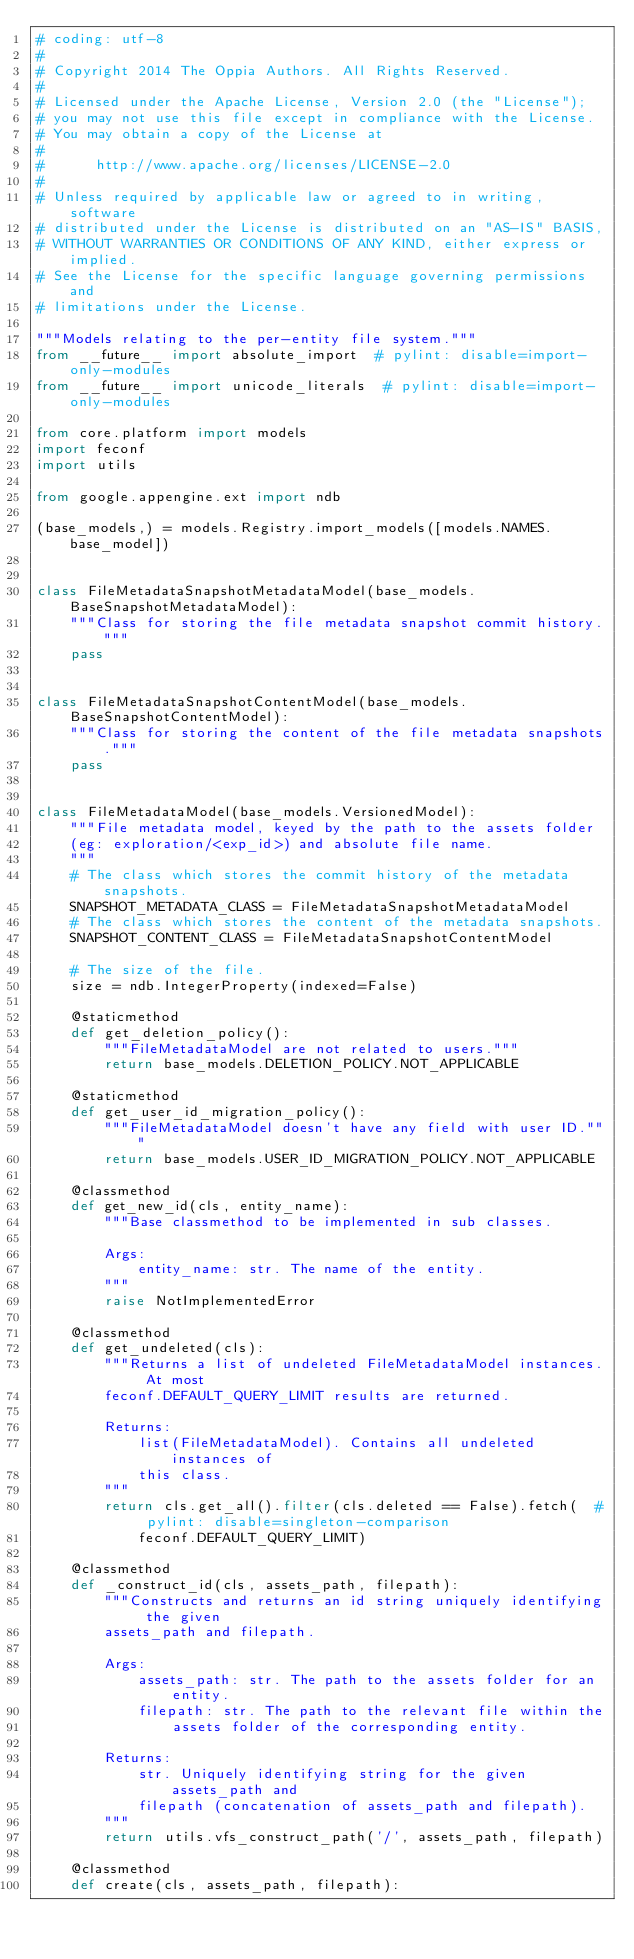Convert code to text. <code><loc_0><loc_0><loc_500><loc_500><_Python_># coding: utf-8
#
# Copyright 2014 The Oppia Authors. All Rights Reserved.
#
# Licensed under the Apache License, Version 2.0 (the "License");
# you may not use this file except in compliance with the License.
# You may obtain a copy of the License at
#
#      http://www.apache.org/licenses/LICENSE-2.0
#
# Unless required by applicable law or agreed to in writing, software
# distributed under the License is distributed on an "AS-IS" BASIS,
# WITHOUT WARRANTIES OR CONDITIONS OF ANY KIND, either express or implied.
# See the License for the specific language governing permissions and
# limitations under the License.

"""Models relating to the per-entity file system."""
from __future__ import absolute_import  # pylint: disable=import-only-modules
from __future__ import unicode_literals  # pylint: disable=import-only-modules

from core.platform import models
import feconf
import utils

from google.appengine.ext import ndb

(base_models,) = models.Registry.import_models([models.NAMES.base_model])


class FileMetadataSnapshotMetadataModel(base_models.BaseSnapshotMetadataModel):
    """Class for storing the file metadata snapshot commit history."""
    pass


class FileMetadataSnapshotContentModel(base_models.BaseSnapshotContentModel):
    """Class for storing the content of the file metadata snapshots."""
    pass


class FileMetadataModel(base_models.VersionedModel):
    """File metadata model, keyed by the path to the assets folder
    (eg: exploration/<exp_id>) and absolute file name.
    """
    # The class which stores the commit history of the metadata snapshots.
    SNAPSHOT_METADATA_CLASS = FileMetadataSnapshotMetadataModel
    # The class which stores the content of the metadata snapshots.
    SNAPSHOT_CONTENT_CLASS = FileMetadataSnapshotContentModel

    # The size of the file.
    size = ndb.IntegerProperty(indexed=False)

    @staticmethod
    def get_deletion_policy():
        """FileMetadataModel are not related to users."""
        return base_models.DELETION_POLICY.NOT_APPLICABLE

    @staticmethod
    def get_user_id_migration_policy():
        """FileMetadataModel doesn't have any field with user ID."""
        return base_models.USER_ID_MIGRATION_POLICY.NOT_APPLICABLE

    @classmethod
    def get_new_id(cls, entity_name):
        """Base classmethod to be implemented in sub classes.

        Args:
            entity_name: str. The name of the entity.
        """
        raise NotImplementedError

    @classmethod
    def get_undeleted(cls):
        """Returns a list of undeleted FileMetadataModel instances. At most
        feconf.DEFAULT_QUERY_LIMIT results are returned.

        Returns:
            list(FileMetadataModel). Contains all undeleted instances of
            this class.
        """
        return cls.get_all().filter(cls.deleted == False).fetch(  # pylint: disable=singleton-comparison
            feconf.DEFAULT_QUERY_LIMIT)

    @classmethod
    def _construct_id(cls, assets_path, filepath):
        """Constructs and returns an id string uniquely identifying the given
        assets_path and filepath.

        Args:
            assets_path: str. The path to the assets folder for an entity.
            filepath: str. The path to the relevant file within the
                assets folder of the corresponding entity.

        Returns:
            str. Uniquely identifying string for the given assets_path and
            filepath (concatenation of assets_path and filepath).
        """
        return utils.vfs_construct_path('/', assets_path, filepath)

    @classmethod
    def create(cls, assets_path, filepath):</code> 